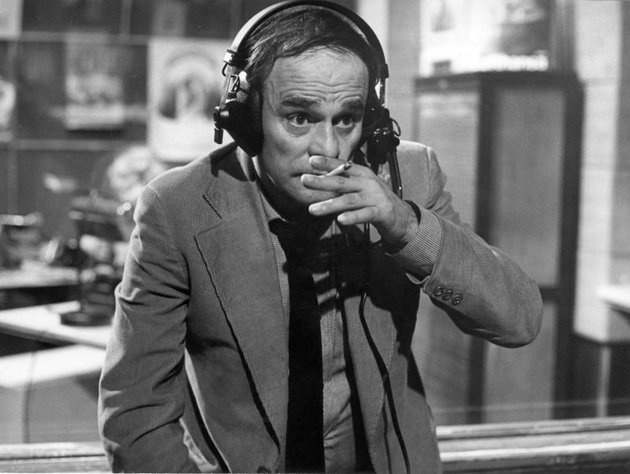What if this studio is part of a fictional world? Describe that world and the type of radio shows this DJ might host. In a fictional steampunk world, this radio studio could be part of an airship floating above a bustling, clockwork-laden metropolis. The DJ, dressed in a Victorian-era suit with technological enhancements, might host shows that cater to adventurers, inventors, and historians. Programs could range from live reports on sky pirates to interviews with renowned explorers mapping uncharted territories. The posters would depict airship races, mechanical wonders, and sketches of fantastical creatures. The DJ's job would involve not just entertaining but also providing crucial information, safety tips for airship travel, and updates on the latest technological marvels discovered across the empire. 